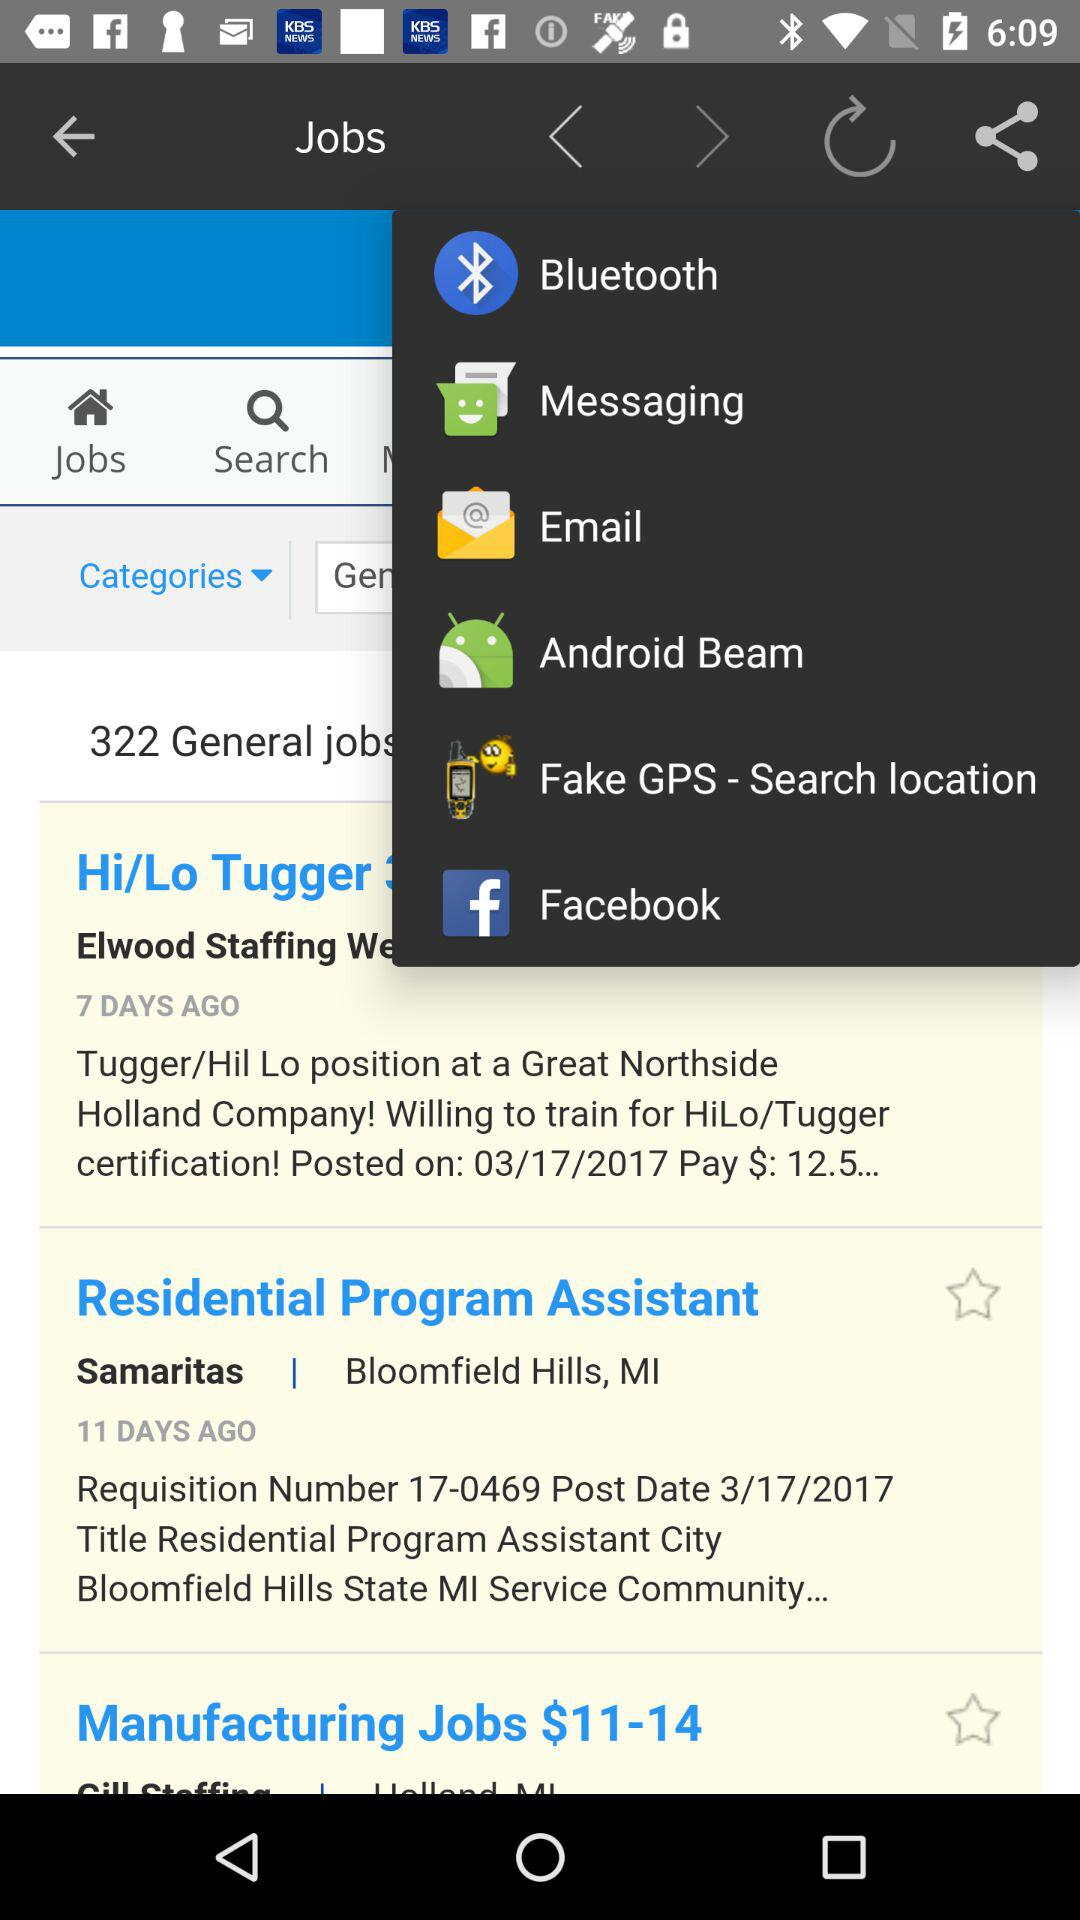Through which applications can we share? You can share through "Bluetooth", "Messaging", "Email", "Android Beam", "Fake GPS - Search location" and "Facebook". 